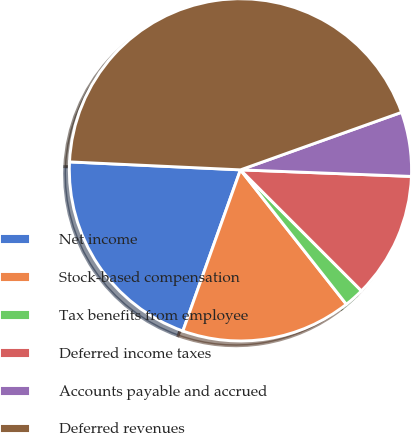Convert chart to OTSL. <chart><loc_0><loc_0><loc_500><loc_500><pie_chart><fcel>Net income<fcel>Stock-based compensation<fcel>Tax benefits from employee<fcel>Deferred income taxes<fcel>Accounts payable and accrued<fcel>Deferred revenues<nl><fcel>20.28%<fcel>16.08%<fcel>1.88%<fcel>11.89%<fcel>6.07%<fcel>43.8%<nl></chart> 